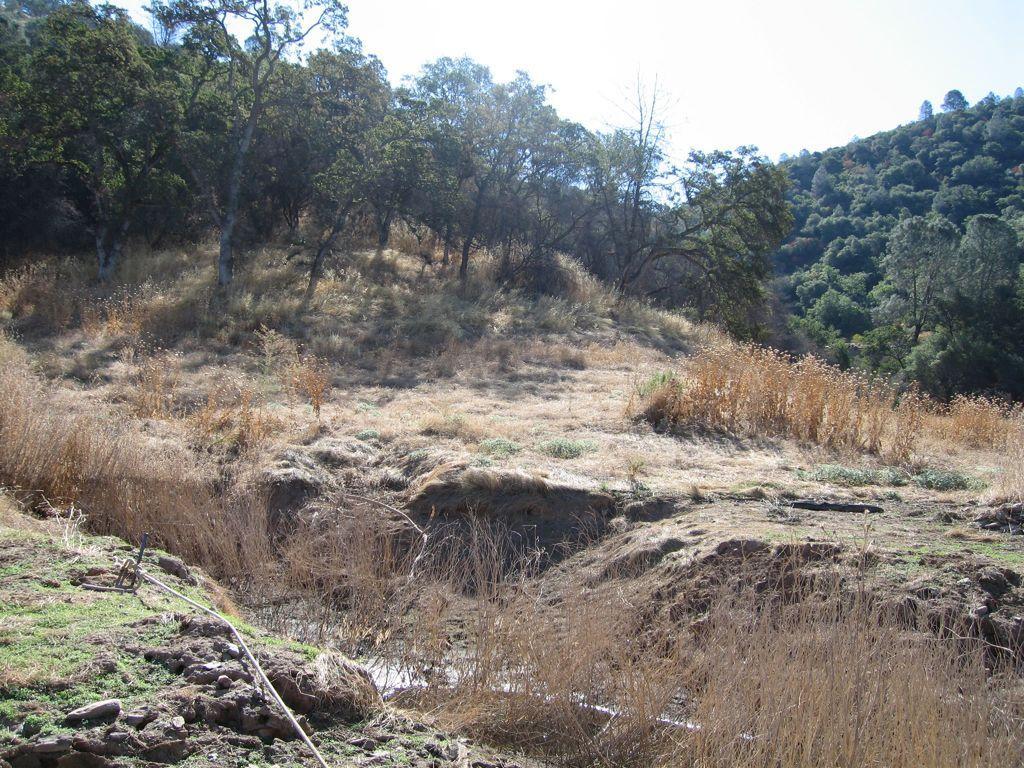Describe this image in one or two sentences. This picture consists of forest , in the forest I can see grass , trees ,the sky at the top and the rope at the bottom. 